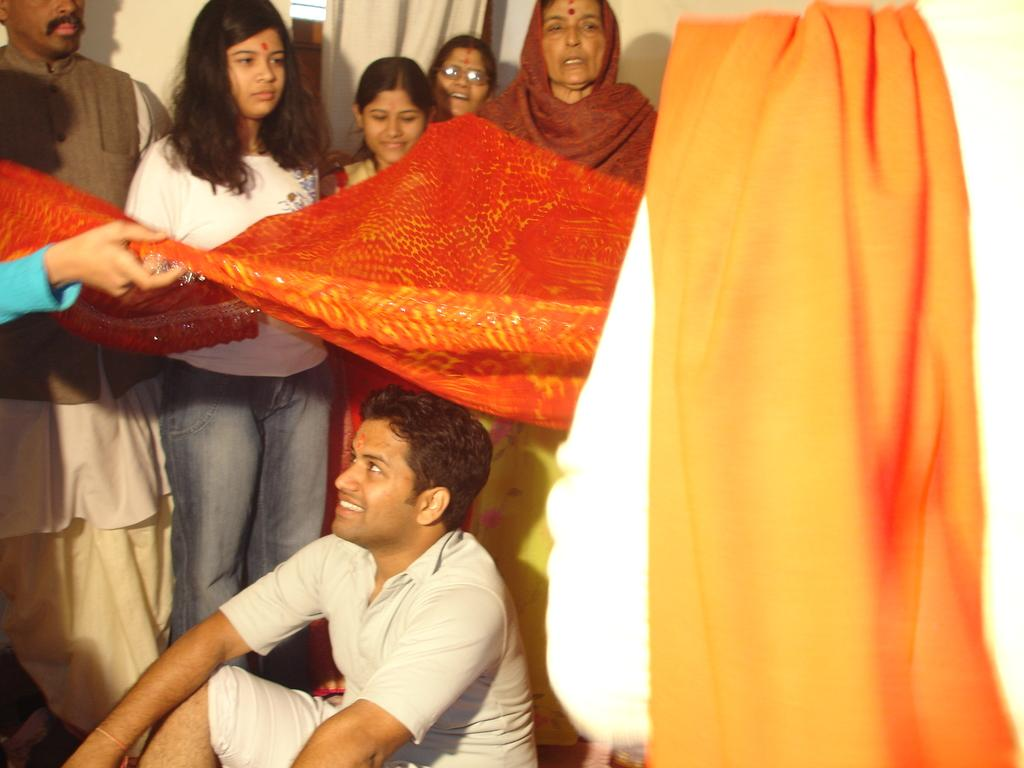What is the man in the image doing? The man is sitting at the bottom of the image. What is the man's facial expression? The man is smiling. What is above the man in the image? There is a cloth above the man. How many people are standing in the image? There are people standing in the image. What can be seen in the background of the image? There is a wall and a curtain in the background of the image. What type of collar can be seen on the man in the image? There is no collar visible on the man in the image. What joke is the man telling to the people standing in the image? There is no indication of a joke being told in the image; the man is simply smiling. 